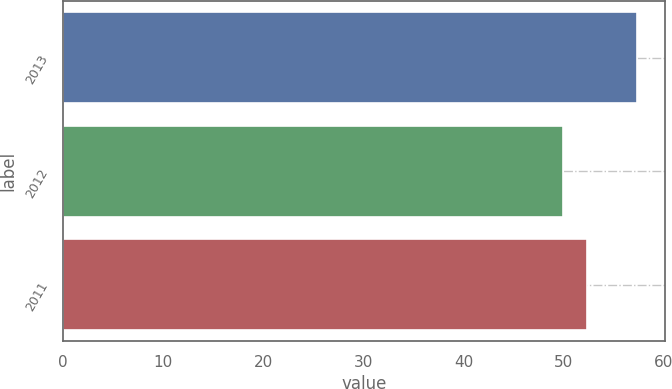Convert chart. <chart><loc_0><loc_0><loc_500><loc_500><bar_chart><fcel>2013<fcel>2012<fcel>2011<nl><fcel>57.3<fcel>49.9<fcel>52.3<nl></chart> 